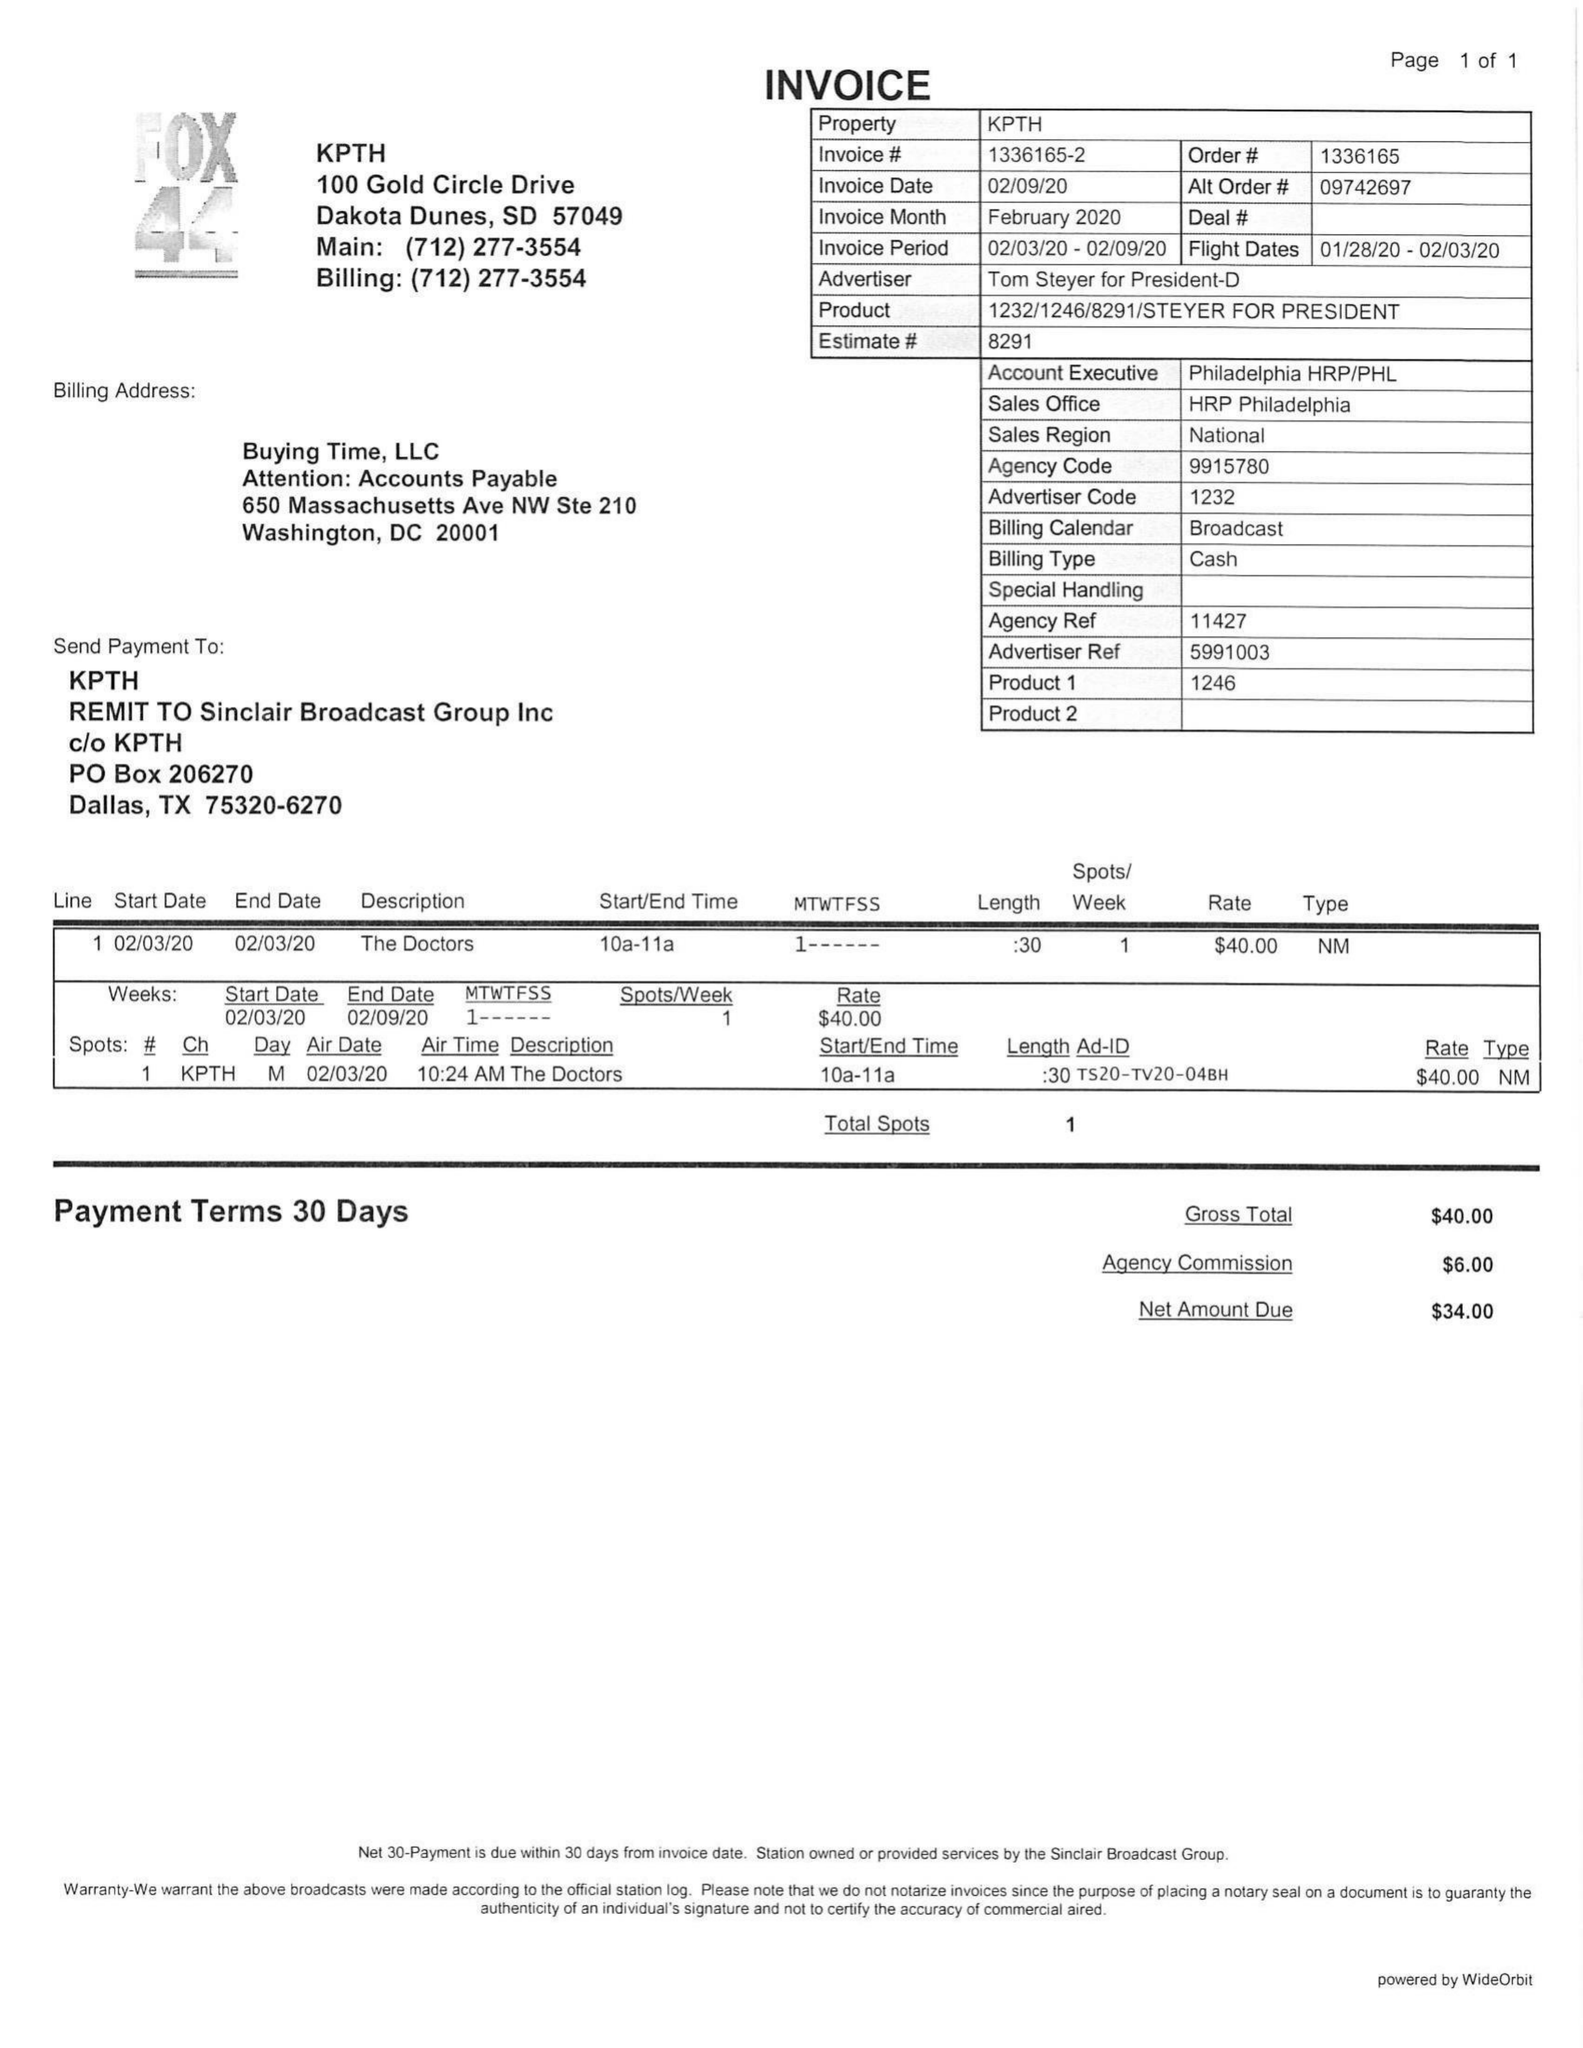What is the value for the gross_amount?
Answer the question using a single word or phrase. 40.00 